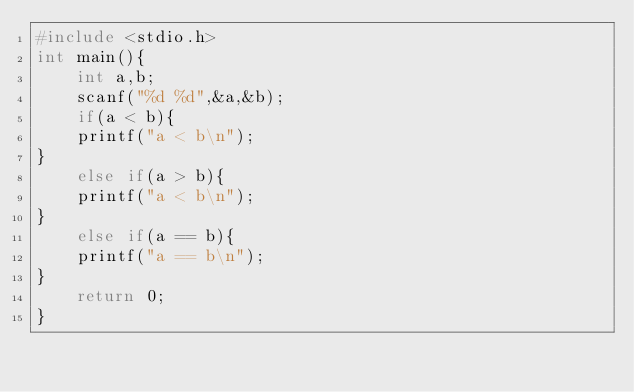Convert code to text. <code><loc_0><loc_0><loc_500><loc_500><_C_>#include <stdio.h>
int main(){
    int a,b;
    scanf("%d %d",&a,&b);
    if(a < b){
    printf("a < b\n");
}
    else if(a > b){
    printf("a < b\n");
}
    else if(a == b){
    printf("a == b\n");
}
    return 0;
}
</code> 